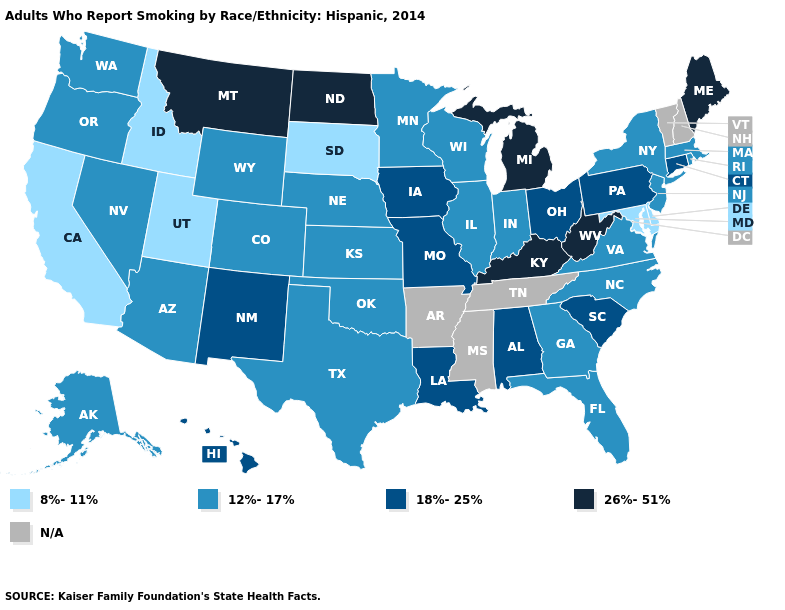Which states have the highest value in the USA?
Write a very short answer. Kentucky, Maine, Michigan, Montana, North Dakota, West Virginia. Name the states that have a value in the range 26%-51%?
Concise answer only. Kentucky, Maine, Michigan, Montana, North Dakota, West Virginia. What is the highest value in the South ?
Give a very brief answer. 26%-51%. Name the states that have a value in the range 26%-51%?
Be succinct. Kentucky, Maine, Michigan, Montana, North Dakota, West Virginia. Among the states that border Virginia , which have the highest value?
Short answer required. Kentucky, West Virginia. What is the lowest value in states that border Oklahoma?
Be succinct. 12%-17%. Which states have the highest value in the USA?
Write a very short answer. Kentucky, Maine, Michigan, Montana, North Dakota, West Virginia. What is the value of Rhode Island?
Be succinct. 12%-17%. Does the map have missing data?
Keep it brief. Yes. Is the legend a continuous bar?
Write a very short answer. No. What is the lowest value in the USA?
Keep it brief. 8%-11%. 